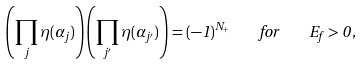Convert formula to latex. <formula><loc_0><loc_0><loc_500><loc_500>\left ( \prod _ { j } \eta ( \alpha _ { j } ) \right ) \left ( \prod _ { j ^ { \prime } } \eta ( \alpha _ { j ^ { \prime } } ) \right ) = ( - 1 ) ^ { N _ { + } } \quad f o r \quad E _ { f } > 0 \, ,</formula> 